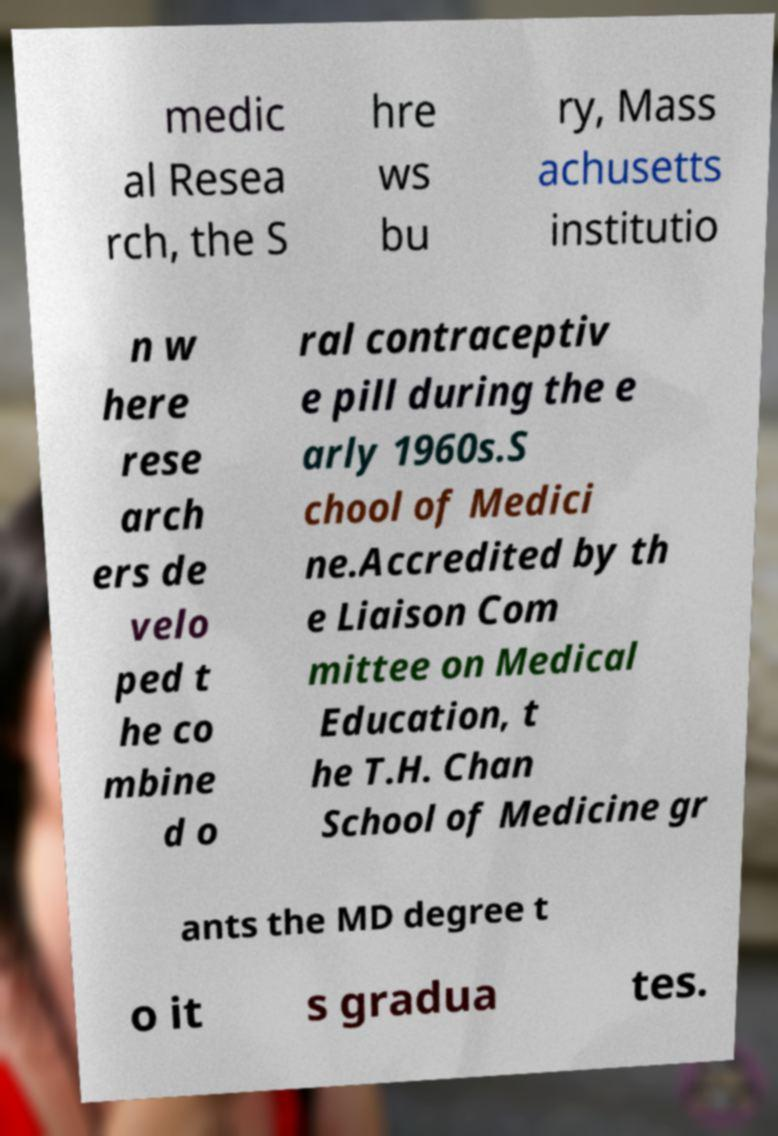Can you accurately transcribe the text from the provided image for me? medic al Resea rch, the S hre ws bu ry, Mass achusetts institutio n w here rese arch ers de velo ped t he co mbine d o ral contraceptiv e pill during the e arly 1960s.S chool of Medici ne.Accredited by th e Liaison Com mittee on Medical Education, t he T.H. Chan School of Medicine gr ants the MD degree t o it s gradua tes. 